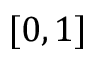<formula> <loc_0><loc_0><loc_500><loc_500>[ 0 , 1 ]</formula> 